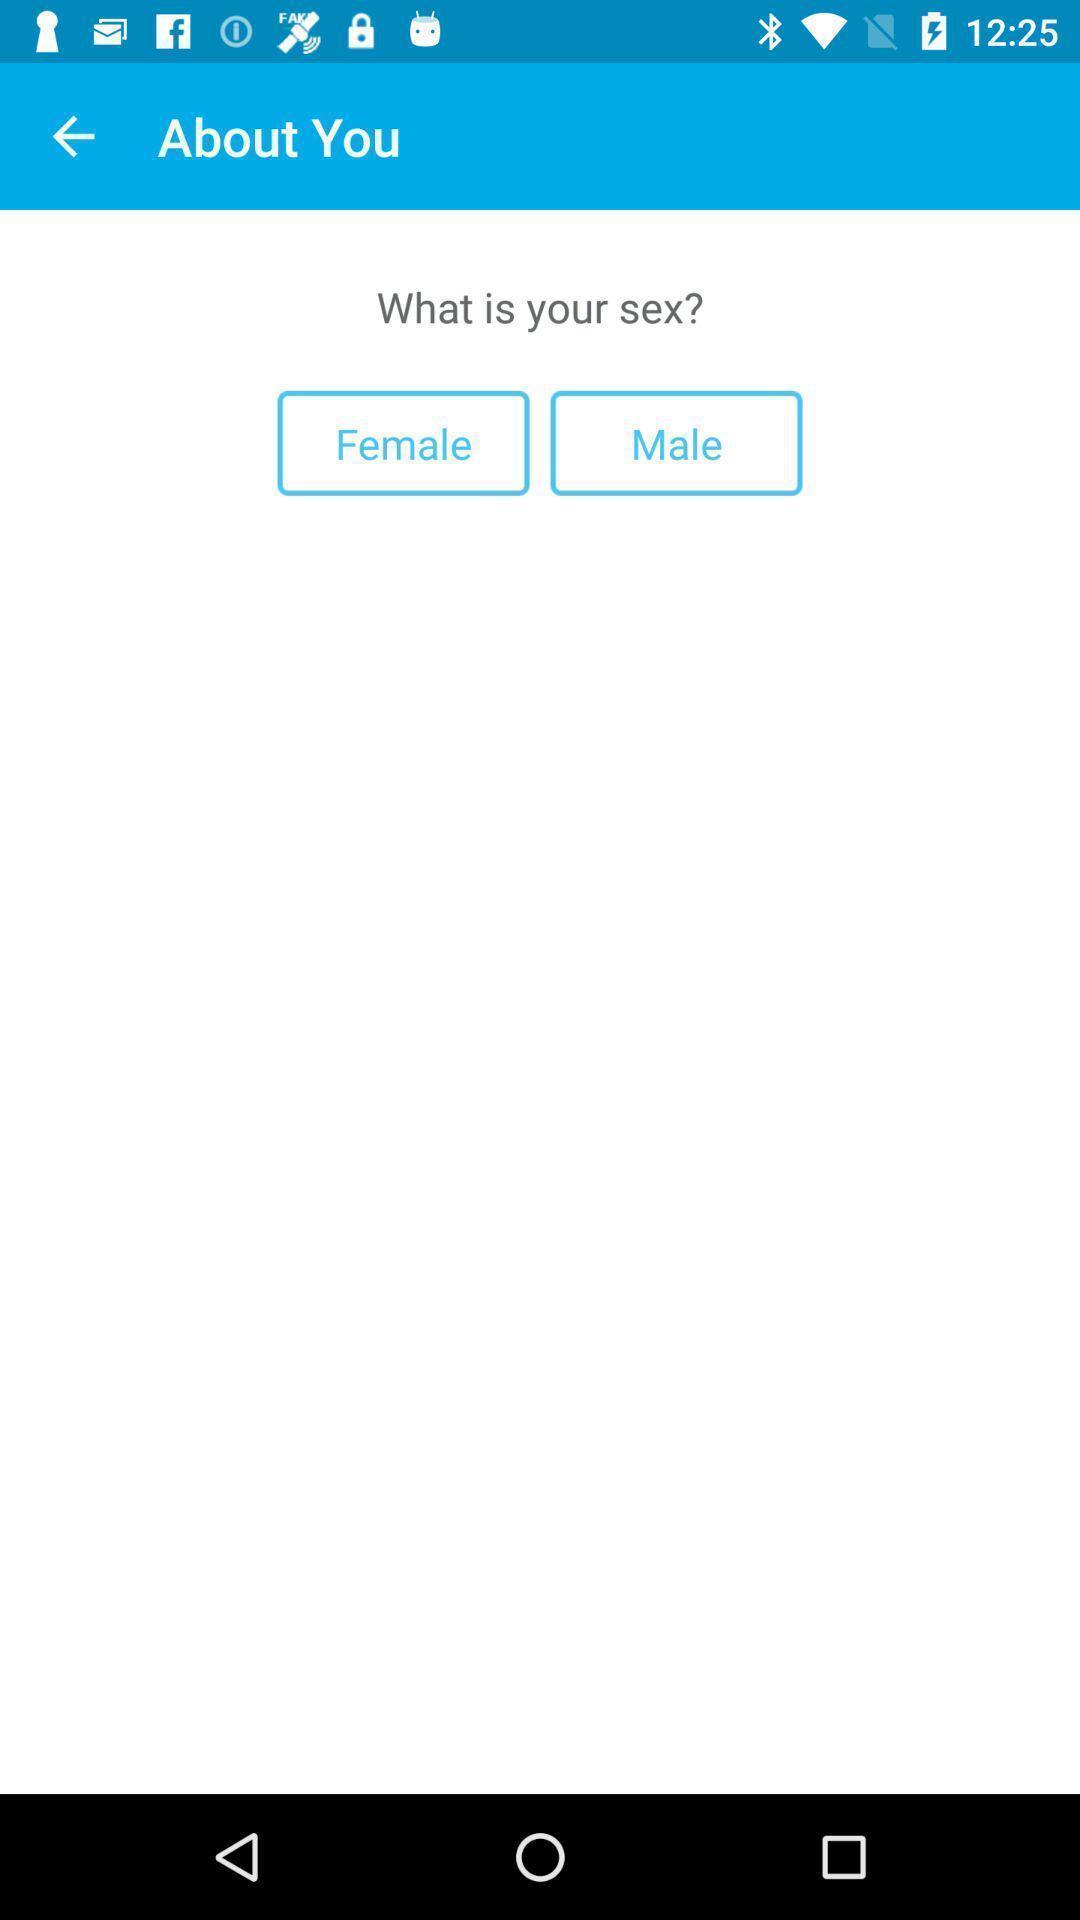Tell me what you see in this picture. Screen displaying options to select sex. 